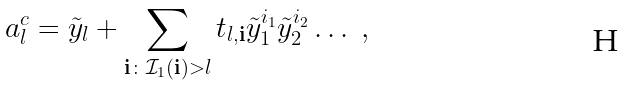Convert formula to latex. <formula><loc_0><loc_0><loc_500><loc_500>a _ { l } ^ { c } = \tilde { y } _ { l } + \sum _ { { \mathbf i } \colon { \mathcal { I } } _ { 1 } ( { \mathbf i } ) > l } t _ { l , { \mathbf i } } { \tilde { y } } _ { 1 } ^ { i _ { 1 } } { \tilde { y } } _ { 2 } ^ { i _ { 2 } } \dots \ ,</formula> 